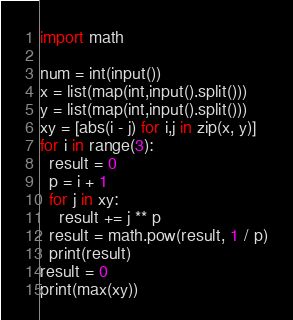<code> <loc_0><loc_0><loc_500><loc_500><_Python_>import math

num = int(input())
x = list(map(int,input().split()))
y = list(map(int,input().split()))
xy = [abs(i - j) for i,j in zip(x, y)] 
for i in range(3):
  result = 0
  p = i + 1
  for j in xy:
    result += j ** p
  result = math.pow(result, 1 / p)
  print(result)
result = 0
print(max(xy))
</code> 